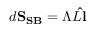<formula> <loc_0><loc_0><loc_500><loc_500>d S _ { S B } = \Lambda L \hat { l }</formula> 